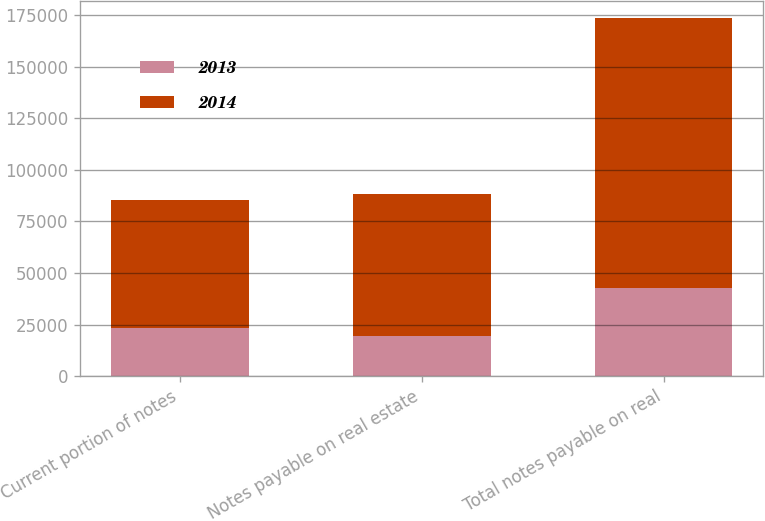Convert chart. <chart><loc_0><loc_0><loc_500><loc_500><stacked_bar_chart><ecel><fcel>Current portion of notes<fcel>Notes payable on real estate<fcel>Total notes payable on real<nl><fcel>2013<fcel>23229<fcel>19614<fcel>42843<nl><fcel>2014<fcel>62017<fcel>68455<fcel>130472<nl></chart> 